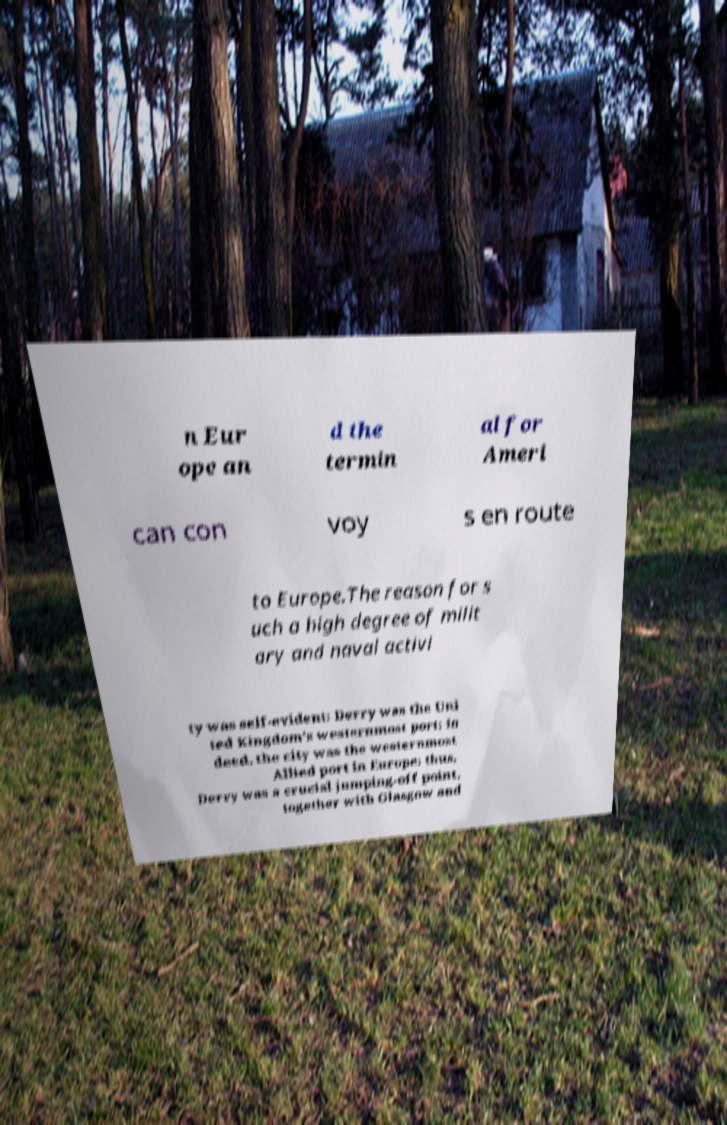Could you assist in decoding the text presented in this image and type it out clearly? n Eur ope an d the termin al for Ameri can con voy s en route to Europe.The reason for s uch a high degree of milit ary and naval activi ty was self-evident: Derry was the Uni ted Kingdom's westernmost port; in deed, the city was the westernmost Allied port in Europe: thus, Derry was a crucial jumping-off point, together with Glasgow and 